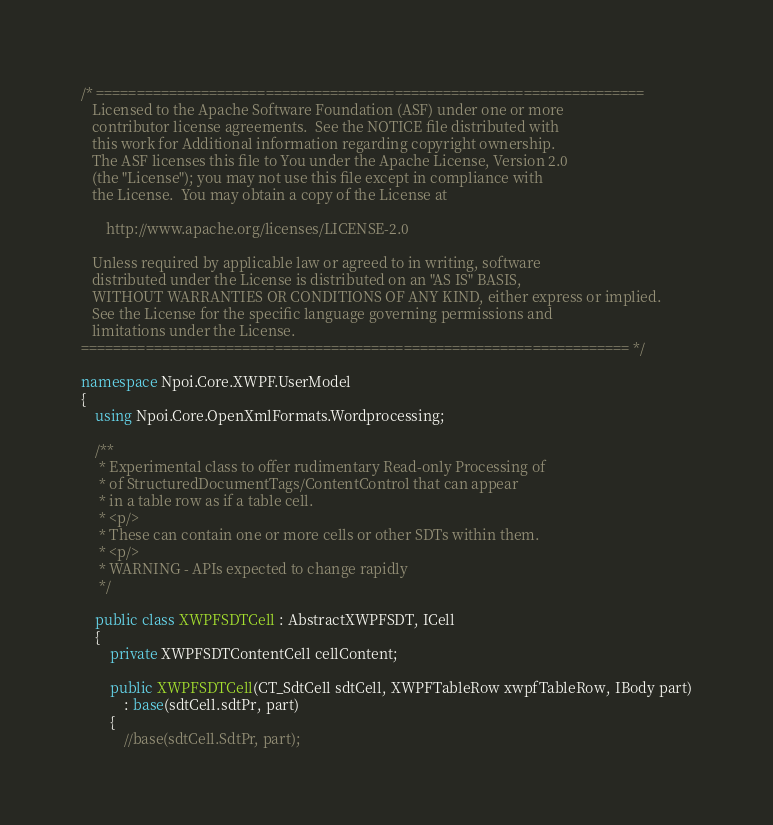<code> <loc_0><loc_0><loc_500><loc_500><_C#_>/* ====================================================================
   Licensed to the Apache Software Foundation (ASF) under one or more
   contributor license agreements.  See the NOTICE file distributed with
   this work for Additional information regarding copyright ownership.
   The ASF licenses this file to You under the Apache License, Version 2.0
   (the "License"); you may not use this file except in compliance with
   the License.  You may obtain a copy of the License at

       http://www.apache.org/licenses/LICENSE-2.0

   Unless required by applicable law or agreed to in writing, software
   distributed under the License is distributed on an "AS IS" BASIS,
   WITHOUT WARRANTIES OR CONDITIONS OF ANY KIND, either express or implied.
   See the License for the specific language governing permissions and
   limitations under the License.
==================================================================== */

namespace Npoi.Core.XWPF.UserModel
{
    using Npoi.Core.OpenXmlFormats.Wordprocessing;

    /**
     * Experimental class to offer rudimentary Read-only Processing of
     * of StructuredDocumentTags/ContentControl that can appear
     * in a table row as if a table cell.
     * <p/>
     * These can contain one or more cells or other SDTs within them.
     * <p/>
     * WARNING - APIs expected to change rapidly
     */

    public class XWPFSDTCell : AbstractXWPFSDT, ICell
    {
        private XWPFSDTContentCell cellContent;

        public XWPFSDTCell(CT_SdtCell sdtCell, XWPFTableRow xwpfTableRow, IBody part)
            : base(sdtCell.sdtPr, part)
        {
            //base(sdtCell.SdtPr, part);</code> 